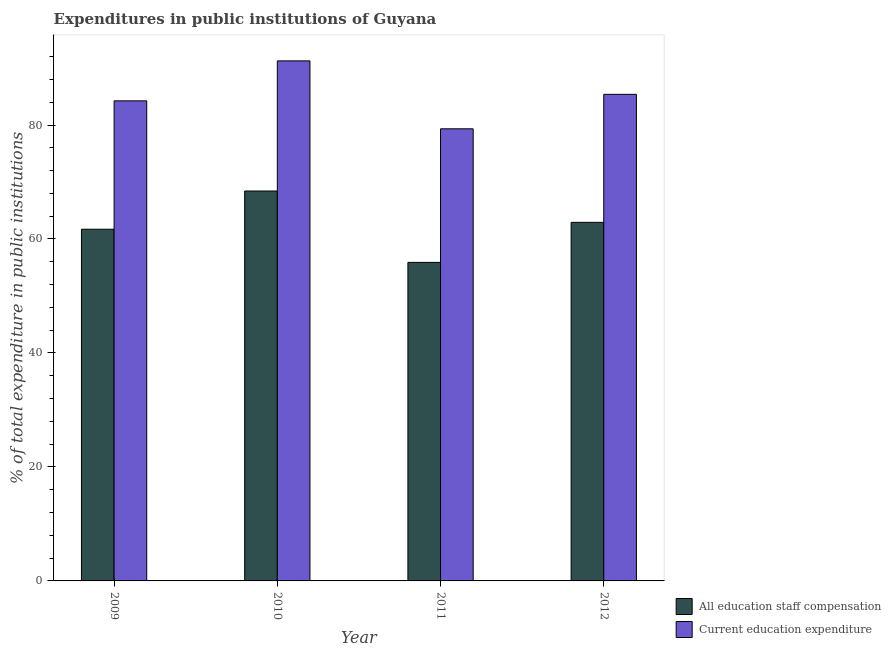How many groups of bars are there?
Give a very brief answer. 4. Are the number of bars per tick equal to the number of legend labels?
Offer a very short reply. Yes. How many bars are there on the 3rd tick from the left?
Provide a succinct answer. 2. How many bars are there on the 1st tick from the right?
Keep it short and to the point. 2. In how many cases, is the number of bars for a given year not equal to the number of legend labels?
Ensure brevity in your answer.  0. What is the expenditure in education in 2012?
Offer a very short reply. 85.39. Across all years, what is the maximum expenditure in education?
Offer a very short reply. 91.26. Across all years, what is the minimum expenditure in education?
Make the answer very short. 79.34. What is the total expenditure in education in the graph?
Provide a succinct answer. 340.22. What is the difference between the expenditure in education in 2010 and that in 2012?
Offer a very short reply. 5.87. What is the difference between the expenditure in education in 2012 and the expenditure in staff compensation in 2009?
Give a very brief answer. 1.14. What is the average expenditure in staff compensation per year?
Offer a very short reply. 62.24. In how many years, is the expenditure in staff compensation greater than 52 %?
Provide a short and direct response. 4. What is the ratio of the expenditure in education in 2010 to that in 2012?
Keep it short and to the point. 1.07. Is the difference between the expenditure in education in 2010 and 2012 greater than the difference between the expenditure in staff compensation in 2010 and 2012?
Provide a short and direct response. No. What is the difference between the highest and the second highest expenditure in education?
Offer a terse response. 5.87. What is the difference between the highest and the lowest expenditure in staff compensation?
Ensure brevity in your answer.  12.53. Is the sum of the expenditure in staff compensation in 2010 and 2012 greater than the maximum expenditure in education across all years?
Provide a succinct answer. Yes. What does the 1st bar from the left in 2012 represents?
Offer a terse response. All education staff compensation. What does the 1st bar from the right in 2010 represents?
Keep it short and to the point. Current education expenditure. How many years are there in the graph?
Offer a terse response. 4. What is the difference between two consecutive major ticks on the Y-axis?
Give a very brief answer. 20. Does the graph contain grids?
Provide a short and direct response. No. Where does the legend appear in the graph?
Offer a terse response. Bottom right. What is the title of the graph?
Your answer should be compact. Expenditures in public institutions of Guyana. What is the label or title of the Y-axis?
Your answer should be very brief. % of total expenditure in public institutions. What is the % of total expenditure in public institutions in All education staff compensation in 2009?
Offer a terse response. 61.71. What is the % of total expenditure in public institutions in Current education expenditure in 2009?
Provide a short and direct response. 84.24. What is the % of total expenditure in public institutions of All education staff compensation in 2010?
Your response must be concise. 68.42. What is the % of total expenditure in public institutions of Current education expenditure in 2010?
Offer a terse response. 91.26. What is the % of total expenditure in public institutions of All education staff compensation in 2011?
Provide a short and direct response. 55.9. What is the % of total expenditure in public institutions in Current education expenditure in 2011?
Offer a very short reply. 79.34. What is the % of total expenditure in public institutions of All education staff compensation in 2012?
Keep it short and to the point. 62.92. What is the % of total expenditure in public institutions in Current education expenditure in 2012?
Provide a short and direct response. 85.39. Across all years, what is the maximum % of total expenditure in public institutions of All education staff compensation?
Offer a terse response. 68.42. Across all years, what is the maximum % of total expenditure in public institutions in Current education expenditure?
Your answer should be compact. 91.26. Across all years, what is the minimum % of total expenditure in public institutions in All education staff compensation?
Offer a very short reply. 55.9. Across all years, what is the minimum % of total expenditure in public institutions in Current education expenditure?
Keep it short and to the point. 79.34. What is the total % of total expenditure in public institutions in All education staff compensation in the graph?
Provide a short and direct response. 248.96. What is the total % of total expenditure in public institutions in Current education expenditure in the graph?
Your answer should be compact. 340.22. What is the difference between the % of total expenditure in public institutions in All education staff compensation in 2009 and that in 2010?
Make the answer very short. -6.71. What is the difference between the % of total expenditure in public institutions of Current education expenditure in 2009 and that in 2010?
Your response must be concise. -7.02. What is the difference between the % of total expenditure in public institutions in All education staff compensation in 2009 and that in 2011?
Offer a terse response. 5.82. What is the difference between the % of total expenditure in public institutions of Current education expenditure in 2009 and that in 2011?
Give a very brief answer. 4.9. What is the difference between the % of total expenditure in public institutions of All education staff compensation in 2009 and that in 2012?
Your response must be concise. -1.21. What is the difference between the % of total expenditure in public institutions in Current education expenditure in 2009 and that in 2012?
Offer a terse response. -1.15. What is the difference between the % of total expenditure in public institutions of All education staff compensation in 2010 and that in 2011?
Give a very brief answer. 12.53. What is the difference between the % of total expenditure in public institutions of Current education expenditure in 2010 and that in 2011?
Your response must be concise. 11.92. What is the difference between the % of total expenditure in public institutions of All education staff compensation in 2010 and that in 2012?
Offer a terse response. 5.5. What is the difference between the % of total expenditure in public institutions of Current education expenditure in 2010 and that in 2012?
Your answer should be compact. 5.87. What is the difference between the % of total expenditure in public institutions of All education staff compensation in 2011 and that in 2012?
Your answer should be compact. -7.02. What is the difference between the % of total expenditure in public institutions in Current education expenditure in 2011 and that in 2012?
Offer a terse response. -6.05. What is the difference between the % of total expenditure in public institutions of All education staff compensation in 2009 and the % of total expenditure in public institutions of Current education expenditure in 2010?
Your answer should be compact. -29.54. What is the difference between the % of total expenditure in public institutions in All education staff compensation in 2009 and the % of total expenditure in public institutions in Current education expenditure in 2011?
Offer a very short reply. -17.62. What is the difference between the % of total expenditure in public institutions in All education staff compensation in 2009 and the % of total expenditure in public institutions in Current education expenditure in 2012?
Give a very brief answer. -23.67. What is the difference between the % of total expenditure in public institutions of All education staff compensation in 2010 and the % of total expenditure in public institutions of Current education expenditure in 2011?
Offer a terse response. -10.91. What is the difference between the % of total expenditure in public institutions of All education staff compensation in 2010 and the % of total expenditure in public institutions of Current education expenditure in 2012?
Ensure brevity in your answer.  -16.96. What is the difference between the % of total expenditure in public institutions of All education staff compensation in 2011 and the % of total expenditure in public institutions of Current education expenditure in 2012?
Offer a terse response. -29.49. What is the average % of total expenditure in public institutions of All education staff compensation per year?
Offer a very short reply. 62.24. What is the average % of total expenditure in public institutions in Current education expenditure per year?
Your answer should be compact. 85.06. In the year 2009, what is the difference between the % of total expenditure in public institutions in All education staff compensation and % of total expenditure in public institutions in Current education expenditure?
Your answer should be very brief. -22.53. In the year 2010, what is the difference between the % of total expenditure in public institutions of All education staff compensation and % of total expenditure in public institutions of Current education expenditure?
Provide a succinct answer. -22.83. In the year 2011, what is the difference between the % of total expenditure in public institutions of All education staff compensation and % of total expenditure in public institutions of Current education expenditure?
Keep it short and to the point. -23.44. In the year 2012, what is the difference between the % of total expenditure in public institutions in All education staff compensation and % of total expenditure in public institutions in Current education expenditure?
Keep it short and to the point. -22.47. What is the ratio of the % of total expenditure in public institutions of All education staff compensation in 2009 to that in 2010?
Ensure brevity in your answer.  0.9. What is the ratio of the % of total expenditure in public institutions in All education staff compensation in 2009 to that in 2011?
Provide a short and direct response. 1.1. What is the ratio of the % of total expenditure in public institutions of Current education expenditure in 2009 to that in 2011?
Make the answer very short. 1.06. What is the ratio of the % of total expenditure in public institutions in All education staff compensation in 2009 to that in 2012?
Give a very brief answer. 0.98. What is the ratio of the % of total expenditure in public institutions of Current education expenditure in 2009 to that in 2012?
Provide a succinct answer. 0.99. What is the ratio of the % of total expenditure in public institutions of All education staff compensation in 2010 to that in 2011?
Your answer should be compact. 1.22. What is the ratio of the % of total expenditure in public institutions of Current education expenditure in 2010 to that in 2011?
Your answer should be very brief. 1.15. What is the ratio of the % of total expenditure in public institutions of All education staff compensation in 2010 to that in 2012?
Your answer should be very brief. 1.09. What is the ratio of the % of total expenditure in public institutions in Current education expenditure in 2010 to that in 2012?
Your answer should be compact. 1.07. What is the ratio of the % of total expenditure in public institutions of All education staff compensation in 2011 to that in 2012?
Make the answer very short. 0.89. What is the ratio of the % of total expenditure in public institutions in Current education expenditure in 2011 to that in 2012?
Your answer should be compact. 0.93. What is the difference between the highest and the second highest % of total expenditure in public institutions of All education staff compensation?
Provide a short and direct response. 5.5. What is the difference between the highest and the second highest % of total expenditure in public institutions of Current education expenditure?
Your response must be concise. 5.87. What is the difference between the highest and the lowest % of total expenditure in public institutions in All education staff compensation?
Give a very brief answer. 12.53. What is the difference between the highest and the lowest % of total expenditure in public institutions in Current education expenditure?
Your answer should be very brief. 11.92. 